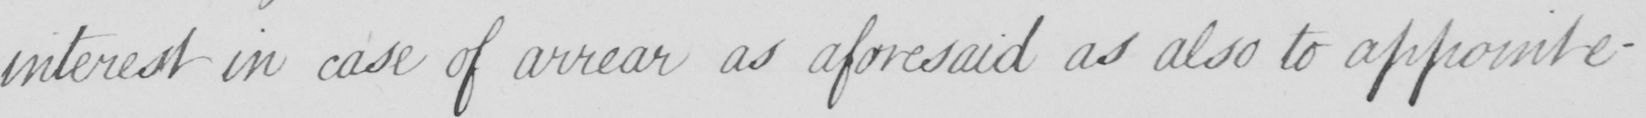Can you tell me what this handwritten text says? interest in case of arrear as aforesaid as also to appoint e- 